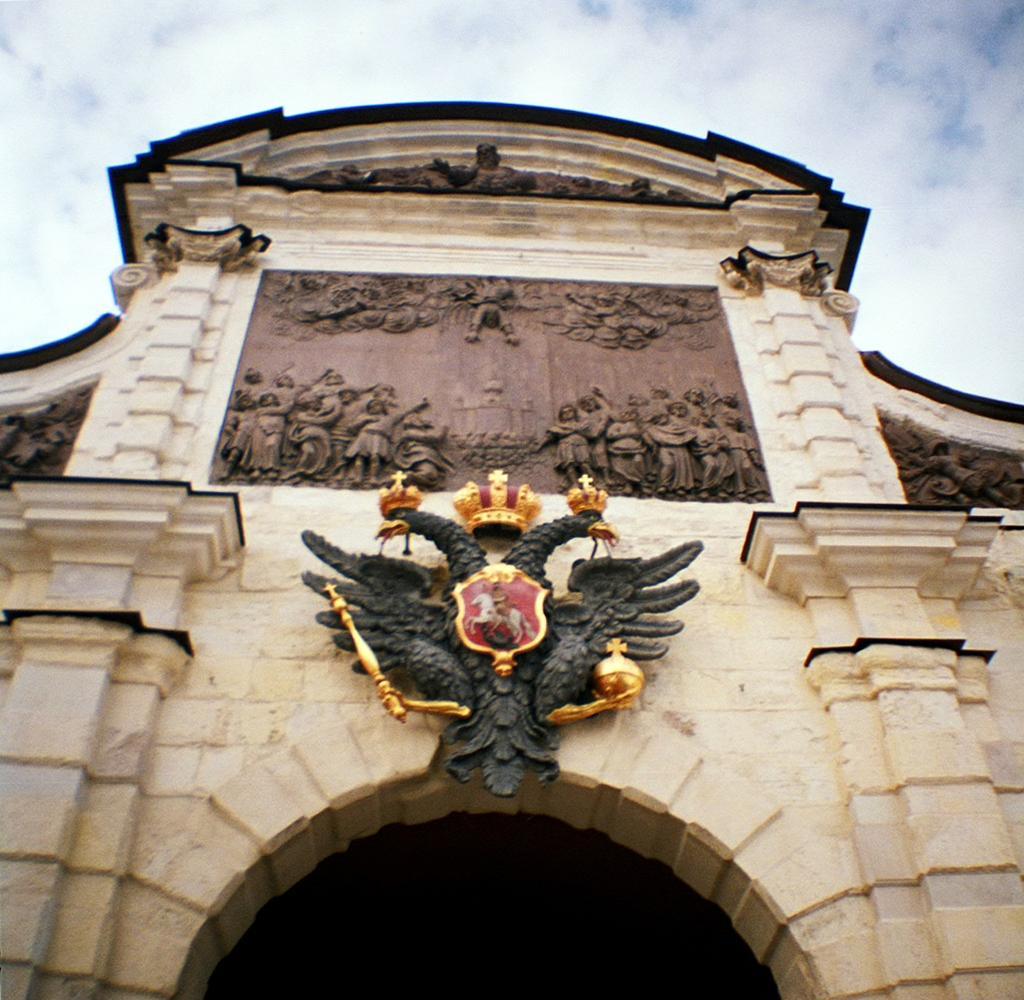In one or two sentences, can you explain what this image depicts? Here in this picture we can see the front view of an historical monument over there and in the middle we can see something present, which is in the shape of an two faced eagle with a crown present on it over there and we can see the sky is fully covered with clouds over there. 